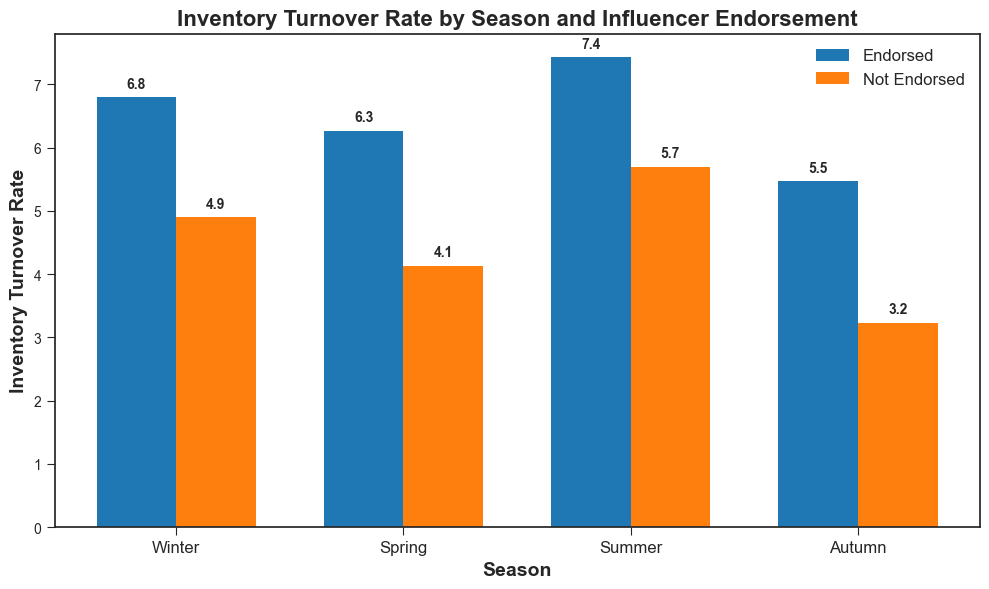Which season has the highest average inventory turnover rate for influencer-endorsed products? Look at the height of the bars labeled "Endorsed" for each season. The tallest bar will indicate the highest average inventory turnover rate.
Answer: Summer What is the difference in the inventory turnover rate between endorsed and not endorsed products in Winter? Subtract the not endorsed rate from the endorsed rate for Winter: 5.4 - 3.2 = 2.2
Answer: 2.2 Compare the average inventory turnover rates in Autumn for endorsed and not endorsed products. Which is higher? Look at the bars for Autumn labeled "Endorsed" and "Not Endorsed". The "Endorsed" bar is higher.
Answer: Endorsed Among all seasons, which has the lowest inventory turnover rate for not endorsed products? Find the shortest bar among those labeled "Not Endorsed" for each season.
Answer: Winter How much higher is the inventory turnover rate for endorsed products compared to not endorsed products in Spring? Subtract the not endorsed rate from the endorsed rate for Spring: 6.2 - 4.1 = 2.1
Answer: 2.1 What is the average inventory turnover rate across all seasons for endorsed products? Add the average rates for each season for endorsed products and divide by 4: (5.4 + 6.2 + 7.4 + 6.8) / 4 = 25.8 / 4 = 6.45
Answer: 6.45 For which season is the difference in inventory turnover rates between endorsed and not endorsed products the smallest? Calculate the differences for each season and find the smallest difference: Winter: 5.4 - 3.2 = 2.2, Spring: 6.2 - 4.1 = 2.1, Summer: 7.4 - 5.7 = 1.7, Autumn: 6.8 - 4.9 = 1.9. Summer has the smallest difference.
Answer: Summer By how much does the inventory turnover rate increase in Summer for endorsed products when compared to Winter for endorsed products? Subtract the Winter endorsed rate from the Summer endorsed rate: 7.4 - 5.4 = 2
Answer: 2 